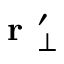Convert formula to latex. <formula><loc_0><loc_0><loc_500><loc_500>r _ { \perp } ^ { \prime }</formula> 